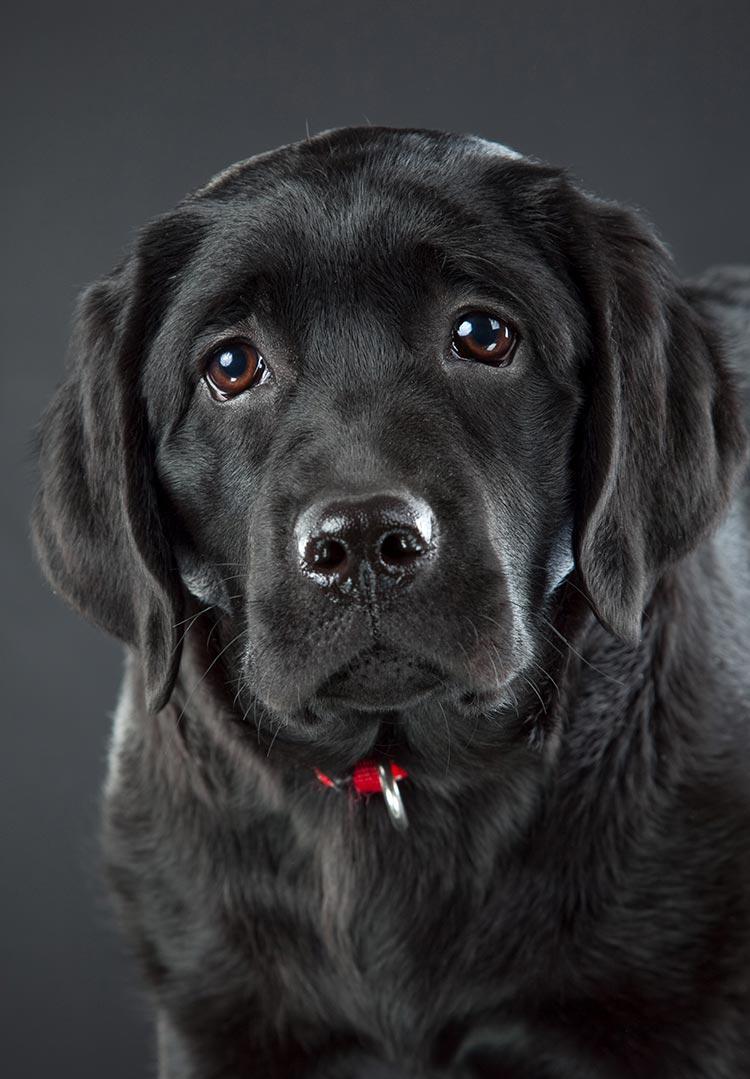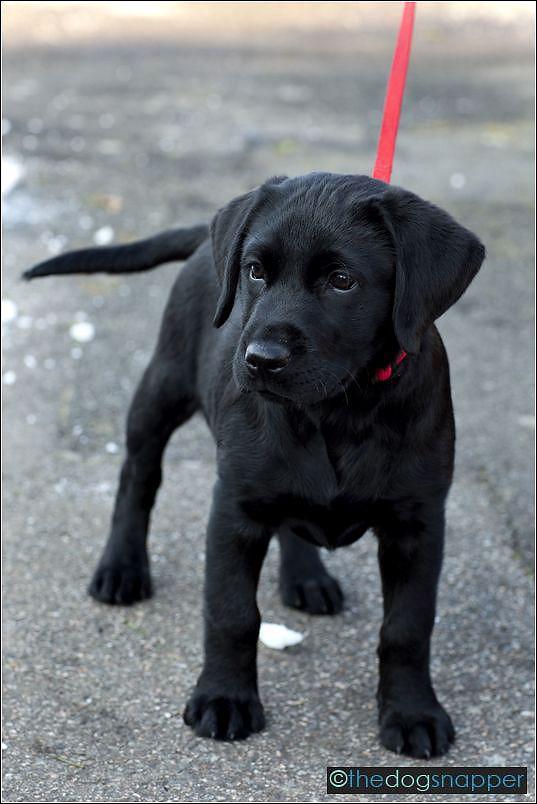The first image is the image on the left, the second image is the image on the right. Analyze the images presented: Is the assertion "In one image, one adult dog has its mouth open showing its tongue and is wearing a collar, while a second image shows a sitting puppy of the same breed." valid? Answer yes or no. No. The first image is the image on the left, the second image is the image on the right. Evaluate the accuracy of this statement regarding the images: "Left image shows a black puppy sitting upright outdoors, but not sitting directly on grass.". Is it true? Answer yes or no. No. 